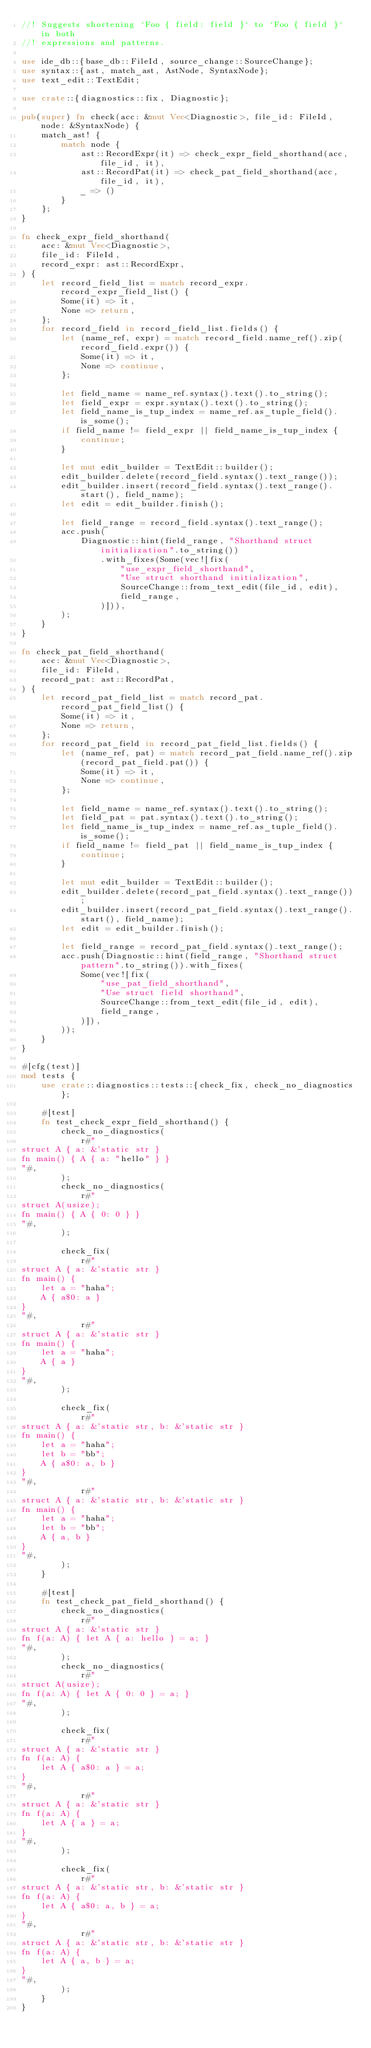Convert code to text. <code><loc_0><loc_0><loc_500><loc_500><_Rust_>//! Suggests shortening `Foo { field: field }` to `Foo { field }` in both
//! expressions and patterns.

use ide_db::{base_db::FileId, source_change::SourceChange};
use syntax::{ast, match_ast, AstNode, SyntaxNode};
use text_edit::TextEdit;

use crate::{diagnostics::fix, Diagnostic};

pub(super) fn check(acc: &mut Vec<Diagnostic>, file_id: FileId, node: &SyntaxNode) {
    match_ast! {
        match node {
            ast::RecordExpr(it) => check_expr_field_shorthand(acc, file_id, it),
            ast::RecordPat(it) => check_pat_field_shorthand(acc, file_id, it),
            _ => ()
        }
    };
}

fn check_expr_field_shorthand(
    acc: &mut Vec<Diagnostic>,
    file_id: FileId,
    record_expr: ast::RecordExpr,
) {
    let record_field_list = match record_expr.record_expr_field_list() {
        Some(it) => it,
        None => return,
    };
    for record_field in record_field_list.fields() {
        let (name_ref, expr) = match record_field.name_ref().zip(record_field.expr()) {
            Some(it) => it,
            None => continue,
        };

        let field_name = name_ref.syntax().text().to_string();
        let field_expr = expr.syntax().text().to_string();
        let field_name_is_tup_index = name_ref.as_tuple_field().is_some();
        if field_name != field_expr || field_name_is_tup_index {
            continue;
        }

        let mut edit_builder = TextEdit::builder();
        edit_builder.delete(record_field.syntax().text_range());
        edit_builder.insert(record_field.syntax().text_range().start(), field_name);
        let edit = edit_builder.finish();

        let field_range = record_field.syntax().text_range();
        acc.push(
            Diagnostic::hint(field_range, "Shorthand struct initialization".to_string())
                .with_fixes(Some(vec![fix(
                    "use_expr_field_shorthand",
                    "Use struct shorthand initialization",
                    SourceChange::from_text_edit(file_id, edit),
                    field_range,
                )])),
        );
    }
}

fn check_pat_field_shorthand(
    acc: &mut Vec<Diagnostic>,
    file_id: FileId,
    record_pat: ast::RecordPat,
) {
    let record_pat_field_list = match record_pat.record_pat_field_list() {
        Some(it) => it,
        None => return,
    };
    for record_pat_field in record_pat_field_list.fields() {
        let (name_ref, pat) = match record_pat_field.name_ref().zip(record_pat_field.pat()) {
            Some(it) => it,
            None => continue,
        };

        let field_name = name_ref.syntax().text().to_string();
        let field_pat = pat.syntax().text().to_string();
        let field_name_is_tup_index = name_ref.as_tuple_field().is_some();
        if field_name != field_pat || field_name_is_tup_index {
            continue;
        }

        let mut edit_builder = TextEdit::builder();
        edit_builder.delete(record_pat_field.syntax().text_range());
        edit_builder.insert(record_pat_field.syntax().text_range().start(), field_name);
        let edit = edit_builder.finish();

        let field_range = record_pat_field.syntax().text_range();
        acc.push(Diagnostic::hint(field_range, "Shorthand struct pattern".to_string()).with_fixes(
            Some(vec![fix(
                "use_pat_field_shorthand",
                "Use struct field shorthand",
                SourceChange::from_text_edit(file_id, edit),
                field_range,
            )]),
        ));
    }
}

#[cfg(test)]
mod tests {
    use crate::diagnostics::tests::{check_fix, check_no_diagnostics};

    #[test]
    fn test_check_expr_field_shorthand() {
        check_no_diagnostics(
            r#"
struct A { a: &'static str }
fn main() { A { a: "hello" } }
"#,
        );
        check_no_diagnostics(
            r#"
struct A(usize);
fn main() { A { 0: 0 } }
"#,
        );

        check_fix(
            r#"
struct A { a: &'static str }
fn main() {
    let a = "haha";
    A { a$0: a }
}
"#,
            r#"
struct A { a: &'static str }
fn main() {
    let a = "haha";
    A { a }
}
"#,
        );

        check_fix(
            r#"
struct A { a: &'static str, b: &'static str }
fn main() {
    let a = "haha";
    let b = "bb";
    A { a$0: a, b }
}
"#,
            r#"
struct A { a: &'static str, b: &'static str }
fn main() {
    let a = "haha";
    let b = "bb";
    A { a, b }
}
"#,
        );
    }

    #[test]
    fn test_check_pat_field_shorthand() {
        check_no_diagnostics(
            r#"
struct A { a: &'static str }
fn f(a: A) { let A { a: hello } = a; }
"#,
        );
        check_no_diagnostics(
            r#"
struct A(usize);
fn f(a: A) { let A { 0: 0 } = a; }
"#,
        );

        check_fix(
            r#"
struct A { a: &'static str }
fn f(a: A) {
    let A { a$0: a } = a;
}
"#,
            r#"
struct A { a: &'static str }
fn f(a: A) {
    let A { a } = a;
}
"#,
        );

        check_fix(
            r#"
struct A { a: &'static str, b: &'static str }
fn f(a: A) {
    let A { a$0: a, b } = a;
}
"#,
            r#"
struct A { a: &'static str, b: &'static str }
fn f(a: A) {
    let A { a, b } = a;
}
"#,
        );
    }
}
</code> 